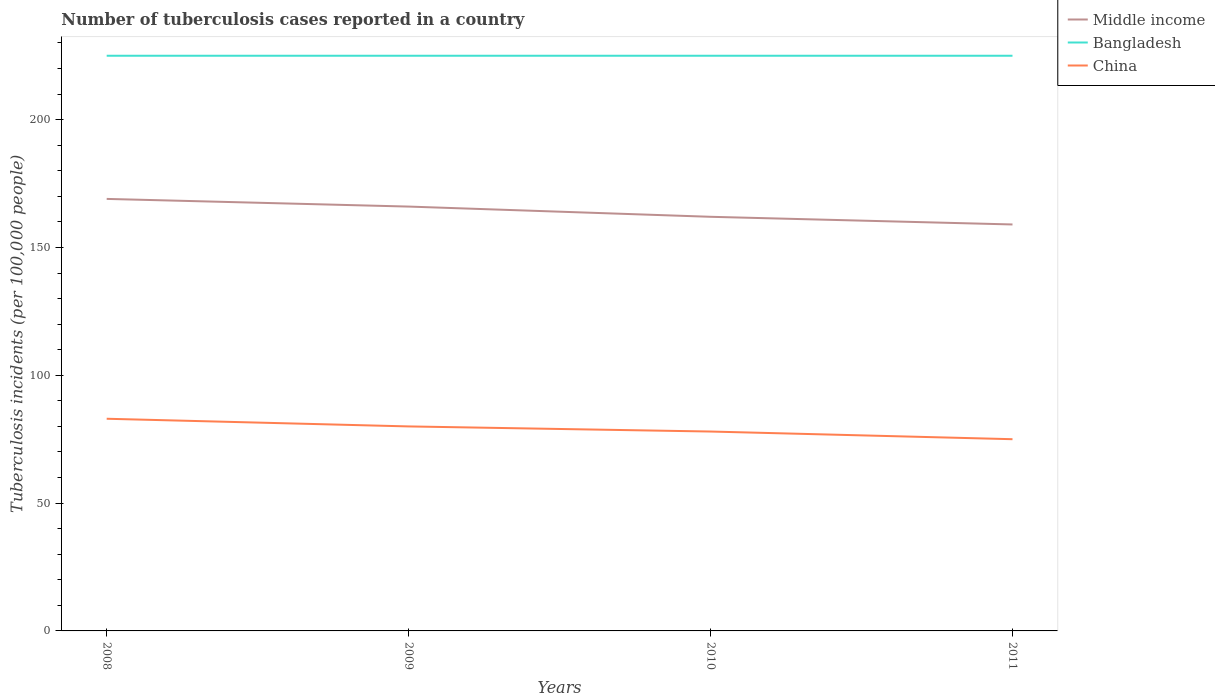Is the number of lines equal to the number of legend labels?
Provide a succinct answer. Yes. Across all years, what is the maximum number of tuberculosis cases reported in in Middle income?
Your answer should be very brief. 159. In which year was the number of tuberculosis cases reported in in Middle income maximum?
Your answer should be compact. 2011. What is the difference between the highest and the second highest number of tuberculosis cases reported in in Bangladesh?
Your answer should be compact. 0. Is the number of tuberculosis cases reported in in China strictly greater than the number of tuberculosis cases reported in in Bangladesh over the years?
Give a very brief answer. Yes. What is the difference between two consecutive major ticks on the Y-axis?
Provide a succinct answer. 50. Are the values on the major ticks of Y-axis written in scientific E-notation?
Provide a succinct answer. No. Does the graph contain grids?
Your response must be concise. No. How many legend labels are there?
Your answer should be compact. 3. How are the legend labels stacked?
Provide a succinct answer. Vertical. What is the title of the graph?
Ensure brevity in your answer.  Number of tuberculosis cases reported in a country. What is the label or title of the X-axis?
Give a very brief answer. Years. What is the label or title of the Y-axis?
Give a very brief answer. Tuberculosis incidents (per 100,0 people). What is the Tuberculosis incidents (per 100,000 people) of Middle income in 2008?
Your response must be concise. 169. What is the Tuberculosis incidents (per 100,000 people) of Bangladesh in 2008?
Offer a terse response. 225. What is the Tuberculosis incidents (per 100,000 people) in Middle income in 2009?
Keep it short and to the point. 166. What is the Tuberculosis incidents (per 100,000 people) in Bangladesh in 2009?
Provide a short and direct response. 225. What is the Tuberculosis incidents (per 100,000 people) in Middle income in 2010?
Your response must be concise. 162. What is the Tuberculosis incidents (per 100,000 people) in Bangladesh in 2010?
Offer a very short reply. 225. What is the Tuberculosis incidents (per 100,000 people) of China in 2010?
Make the answer very short. 78. What is the Tuberculosis incidents (per 100,000 people) in Middle income in 2011?
Give a very brief answer. 159. What is the Tuberculosis incidents (per 100,000 people) of Bangladesh in 2011?
Your answer should be compact. 225. Across all years, what is the maximum Tuberculosis incidents (per 100,000 people) of Middle income?
Provide a short and direct response. 169. Across all years, what is the maximum Tuberculosis incidents (per 100,000 people) of Bangladesh?
Give a very brief answer. 225. Across all years, what is the minimum Tuberculosis incidents (per 100,000 people) of Middle income?
Provide a succinct answer. 159. Across all years, what is the minimum Tuberculosis incidents (per 100,000 people) in Bangladesh?
Provide a succinct answer. 225. Across all years, what is the minimum Tuberculosis incidents (per 100,000 people) in China?
Keep it short and to the point. 75. What is the total Tuberculosis incidents (per 100,000 people) in Middle income in the graph?
Your response must be concise. 656. What is the total Tuberculosis incidents (per 100,000 people) in Bangladesh in the graph?
Keep it short and to the point. 900. What is the total Tuberculosis incidents (per 100,000 people) in China in the graph?
Give a very brief answer. 316. What is the difference between the Tuberculosis incidents (per 100,000 people) in China in 2008 and that in 2009?
Your answer should be very brief. 3. What is the difference between the Tuberculosis incidents (per 100,000 people) of Middle income in 2008 and that in 2010?
Give a very brief answer. 7. What is the difference between the Tuberculosis incidents (per 100,000 people) of Bangladesh in 2008 and that in 2010?
Ensure brevity in your answer.  0. What is the difference between the Tuberculosis incidents (per 100,000 people) of Bangladesh in 2008 and that in 2011?
Make the answer very short. 0. What is the difference between the Tuberculosis incidents (per 100,000 people) in China in 2008 and that in 2011?
Offer a very short reply. 8. What is the difference between the Tuberculosis incidents (per 100,000 people) in China in 2009 and that in 2011?
Your answer should be compact. 5. What is the difference between the Tuberculosis incidents (per 100,000 people) in Bangladesh in 2010 and that in 2011?
Provide a succinct answer. 0. What is the difference between the Tuberculosis incidents (per 100,000 people) of Middle income in 2008 and the Tuberculosis incidents (per 100,000 people) of Bangladesh in 2009?
Make the answer very short. -56. What is the difference between the Tuberculosis incidents (per 100,000 people) in Middle income in 2008 and the Tuberculosis incidents (per 100,000 people) in China in 2009?
Provide a succinct answer. 89. What is the difference between the Tuberculosis incidents (per 100,000 people) of Bangladesh in 2008 and the Tuberculosis incidents (per 100,000 people) of China in 2009?
Make the answer very short. 145. What is the difference between the Tuberculosis incidents (per 100,000 people) in Middle income in 2008 and the Tuberculosis incidents (per 100,000 people) in Bangladesh in 2010?
Make the answer very short. -56. What is the difference between the Tuberculosis incidents (per 100,000 people) in Middle income in 2008 and the Tuberculosis incidents (per 100,000 people) in China in 2010?
Your answer should be compact. 91. What is the difference between the Tuberculosis incidents (per 100,000 people) in Bangladesh in 2008 and the Tuberculosis incidents (per 100,000 people) in China in 2010?
Make the answer very short. 147. What is the difference between the Tuberculosis incidents (per 100,000 people) in Middle income in 2008 and the Tuberculosis incidents (per 100,000 people) in Bangladesh in 2011?
Keep it short and to the point. -56. What is the difference between the Tuberculosis incidents (per 100,000 people) of Middle income in 2008 and the Tuberculosis incidents (per 100,000 people) of China in 2011?
Provide a short and direct response. 94. What is the difference between the Tuberculosis incidents (per 100,000 people) of Bangladesh in 2008 and the Tuberculosis incidents (per 100,000 people) of China in 2011?
Your response must be concise. 150. What is the difference between the Tuberculosis incidents (per 100,000 people) in Middle income in 2009 and the Tuberculosis incidents (per 100,000 people) in Bangladesh in 2010?
Ensure brevity in your answer.  -59. What is the difference between the Tuberculosis incidents (per 100,000 people) of Middle income in 2009 and the Tuberculosis incidents (per 100,000 people) of China in 2010?
Ensure brevity in your answer.  88. What is the difference between the Tuberculosis incidents (per 100,000 people) of Bangladesh in 2009 and the Tuberculosis incidents (per 100,000 people) of China in 2010?
Your answer should be very brief. 147. What is the difference between the Tuberculosis incidents (per 100,000 people) in Middle income in 2009 and the Tuberculosis incidents (per 100,000 people) in Bangladesh in 2011?
Offer a terse response. -59. What is the difference between the Tuberculosis incidents (per 100,000 people) in Middle income in 2009 and the Tuberculosis incidents (per 100,000 people) in China in 2011?
Make the answer very short. 91. What is the difference between the Tuberculosis incidents (per 100,000 people) in Bangladesh in 2009 and the Tuberculosis incidents (per 100,000 people) in China in 2011?
Your answer should be compact. 150. What is the difference between the Tuberculosis incidents (per 100,000 people) of Middle income in 2010 and the Tuberculosis incidents (per 100,000 people) of Bangladesh in 2011?
Ensure brevity in your answer.  -63. What is the difference between the Tuberculosis incidents (per 100,000 people) in Middle income in 2010 and the Tuberculosis incidents (per 100,000 people) in China in 2011?
Your answer should be very brief. 87. What is the difference between the Tuberculosis incidents (per 100,000 people) of Bangladesh in 2010 and the Tuberculosis incidents (per 100,000 people) of China in 2011?
Provide a succinct answer. 150. What is the average Tuberculosis incidents (per 100,000 people) of Middle income per year?
Provide a succinct answer. 164. What is the average Tuberculosis incidents (per 100,000 people) in Bangladesh per year?
Provide a succinct answer. 225. What is the average Tuberculosis incidents (per 100,000 people) of China per year?
Your answer should be very brief. 79. In the year 2008, what is the difference between the Tuberculosis incidents (per 100,000 people) in Middle income and Tuberculosis incidents (per 100,000 people) in Bangladesh?
Give a very brief answer. -56. In the year 2008, what is the difference between the Tuberculosis incidents (per 100,000 people) of Middle income and Tuberculosis incidents (per 100,000 people) of China?
Your answer should be compact. 86. In the year 2008, what is the difference between the Tuberculosis incidents (per 100,000 people) of Bangladesh and Tuberculosis incidents (per 100,000 people) of China?
Ensure brevity in your answer.  142. In the year 2009, what is the difference between the Tuberculosis incidents (per 100,000 people) of Middle income and Tuberculosis incidents (per 100,000 people) of Bangladesh?
Offer a terse response. -59. In the year 2009, what is the difference between the Tuberculosis incidents (per 100,000 people) in Bangladesh and Tuberculosis incidents (per 100,000 people) in China?
Your answer should be very brief. 145. In the year 2010, what is the difference between the Tuberculosis incidents (per 100,000 people) in Middle income and Tuberculosis incidents (per 100,000 people) in Bangladesh?
Your answer should be compact. -63. In the year 2010, what is the difference between the Tuberculosis incidents (per 100,000 people) in Middle income and Tuberculosis incidents (per 100,000 people) in China?
Your answer should be very brief. 84. In the year 2010, what is the difference between the Tuberculosis incidents (per 100,000 people) of Bangladesh and Tuberculosis incidents (per 100,000 people) of China?
Provide a succinct answer. 147. In the year 2011, what is the difference between the Tuberculosis incidents (per 100,000 people) in Middle income and Tuberculosis incidents (per 100,000 people) in Bangladesh?
Ensure brevity in your answer.  -66. In the year 2011, what is the difference between the Tuberculosis incidents (per 100,000 people) in Middle income and Tuberculosis incidents (per 100,000 people) in China?
Ensure brevity in your answer.  84. In the year 2011, what is the difference between the Tuberculosis incidents (per 100,000 people) of Bangladesh and Tuberculosis incidents (per 100,000 people) of China?
Make the answer very short. 150. What is the ratio of the Tuberculosis incidents (per 100,000 people) of Middle income in 2008 to that in 2009?
Your response must be concise. 1.02. What is the ratio of the Tuberculosis incidents (per 100,000 people) of Bangladesh in 2008 to that in 2009?
Provide a succinct answer. 1. What is the ratio of the Tuberculosis incidents (per 100,000 people) in China in 2008 to that in 2009?
Provide a succinct answer. 1.04. What is the ratio of the Tuberculosis incidents (per 100,000 people) in Middle income in 2008 to that in 2010?
Your answer should be compact. 1.04. What is the ratio of the Tuberculosis incidents (per 100,000 people) of Bangladesh in 2008 to that in 2010?
Ensure brevity in your answer.  1. What is the ratio of the Tuberculosis incidents (per 100,000 people) in China in 2008 to that in 2010?
Offer a terse response. 1.06. What is the ratio of the Tuberculosis incidents (per 100,000 people) of Middle income in 2008 to that in 2011?
Make the answer very short. 1.06. What is the ratio of the Tuberculosis incidents (per 100,000 people) of Bangladesh in 2008 to that in 2011?
Your answer should be very brief. 1. What is the ratio of the Tuberculosis incidents (per 100,000 people) of China in 2008 to that in 2011?
Your answer should be compact. 1.11. What is the ratio of the Tuberculosis incidents (per 100,000 people) in Middle income in 2009 to that in 2010?
Your answer should be compact. 1.02. What is the ratio of the Tuberculosis incidents (per 100,000 people) of Bangladesh in 2009 to that in 2010?
Give a very brief answer. 1. What is the ratio of the Tuberculosis incidents (per 100,000 people) in China in 2009 to that in 2010?
Give a very brief answer. 1.03. What is the ratio of the Tuberculosis incidents (per 100,000 people) of Middle income in 2009 to that in 2011?
Provide a succinct answer. 1.04. What is the ratio of the Tuberculosis incidents (per 100,000 people) of China in 2009 to that in 2011?
Give a very brief answer. 1.07. What is the ratio of the Tuberculosis incidents (per 100,000 people) of Middle income in 2010 to that in 2011?
Provide a succinct answer. 1.02. What is the ratio of the Tuberculosis incidents (per 100,000 people) of Bangladesh in 2010 to that in 2011?
Your answer should be very brief. 1. What is the ratio of the Tuberculosis incidents (per 100,000 people) of China in 2010 to that in 2011?
Provide a short and direct response. 1.04. What is the difference between the highest and the second highest Tuberculosis incidents (per 100,000 people) in Middle income?
Keep it short and to the point. 3. What is the difference between the highest and the lowest Tuberculosis incidents (per 100,000 people) of Middle income?
Provide a short and direct response. 10. What is the difference between the highest and the lowest Tuberculosis incidents (per 100,000 people) of Bangladesh?
Your answer should be very brief. 0. 